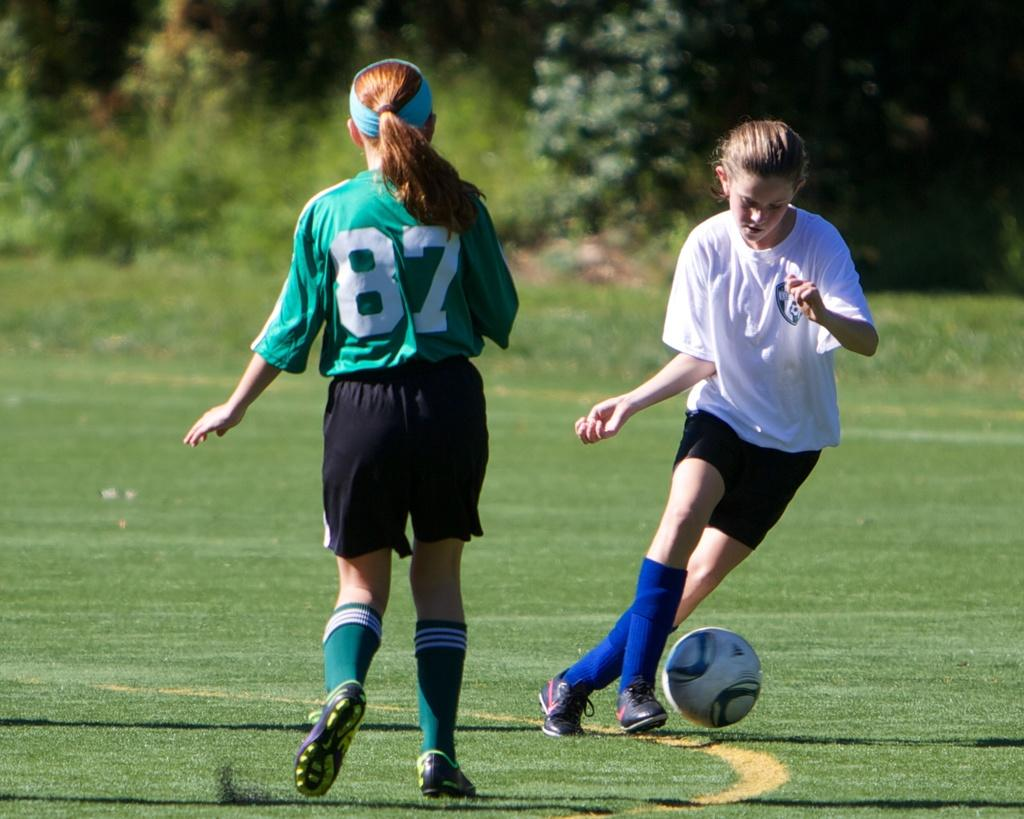How many people are in the image? There are two people in the image. What are the people wearing? The people are wearing different color dresses. What object can be seen in the image besides the people? There is a ball in the image. What type of natural environment is visible in the image? There are trees and grass in the image. What type of mine can be seen in the image? There is no mine present in the image. Can you tell me how many experts are visible in the image? There is no expert visible in the image. 